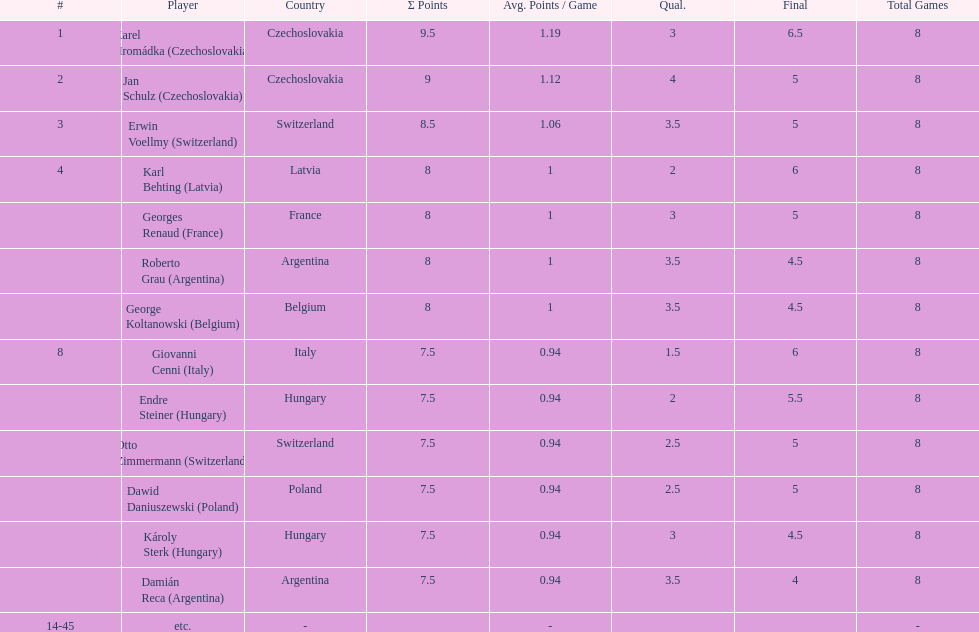What were the concluding scores for karl behting and giovanni cenni? 6. 